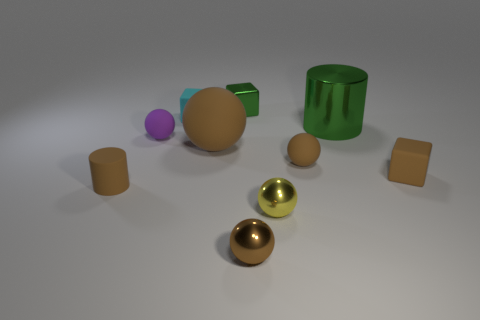Subtract all gray cubes. How many brown balls are left? 3 Subtract all yellow balls. How many balls are left? 4 Subtract all cyan spheres. Subtract all yellow cylinders. How many spheres are left? 5 Subtract all blocks. How many objects are left? 7 Add 5 yellow metallic objects. How many yellow metallic objects exist? 6 Subtract 0 gray balls. How many objects are left? 10 Subtract all tiny objects. Subtract all purple rubber things. How many objects are left? 1 Add 9 tiny cylinders. How many tiny cylinders are left? 10 